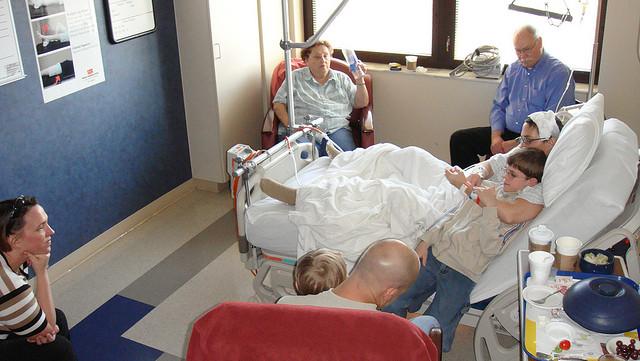How many people are in the picture?
Quick response, please. 7. Does this room have a window?
Answer briefly. Yes. What type of room is this?
Be succinct. Hospital. 